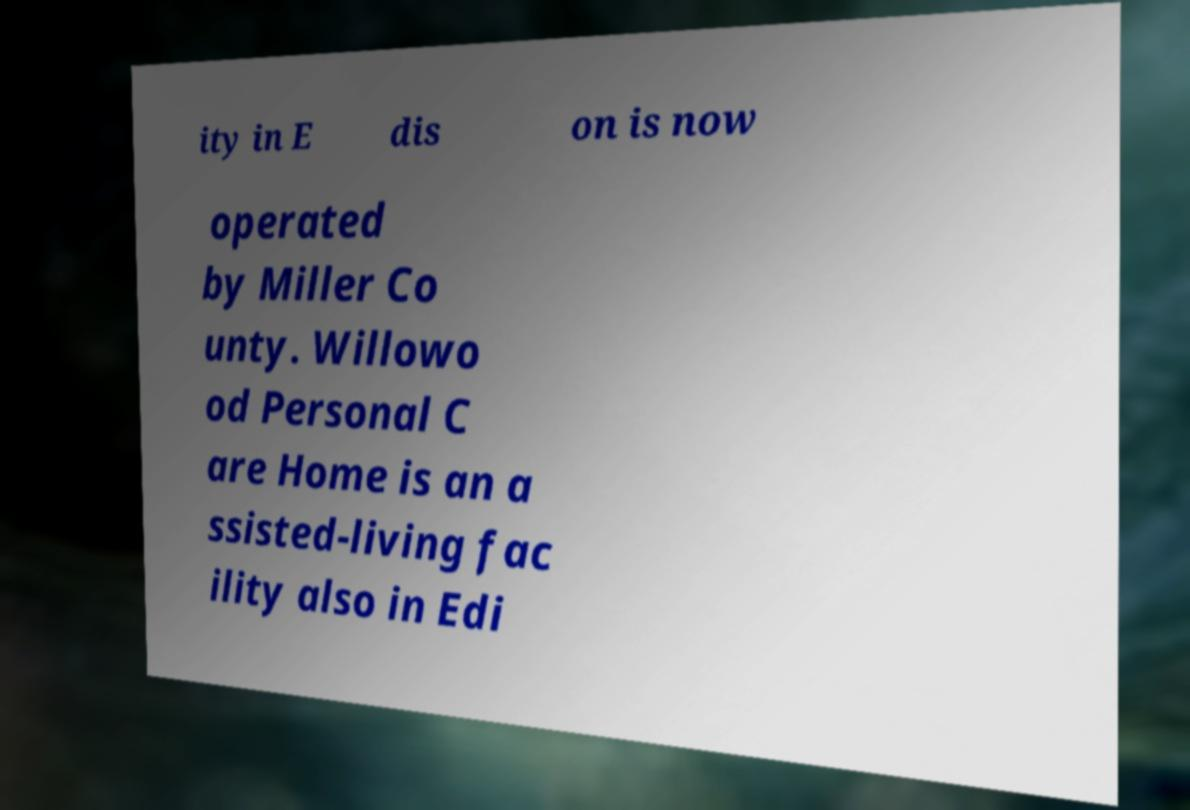What messages or text are displayed in this image? I need them in a readable, typed format. ity in E dis on is now operated by Miller Co unty. Willowo od Personal C are Home is an a ssisted-living fac ility also in Edi 